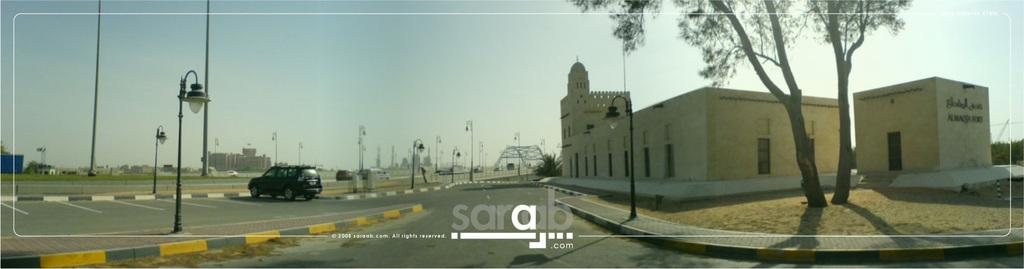What type of structures can be seen in the image? There are buildings in the image. What natural element is present in the image? There is a tree in the image. What type of lighting is present in the image? There are street lights in the image. What type of transportation is visible in the image? There are vehicles in the image. What surface can be seen in the image? There is a road in the image. What is visible in the background of the image? The sky is visible in the image. What type of yarn is being used in the protest in the image? There is no protest or yarn present in the image. On which side of the road are the buildings located in the image? The image does not specify the side of the road on which the buildings are located. 